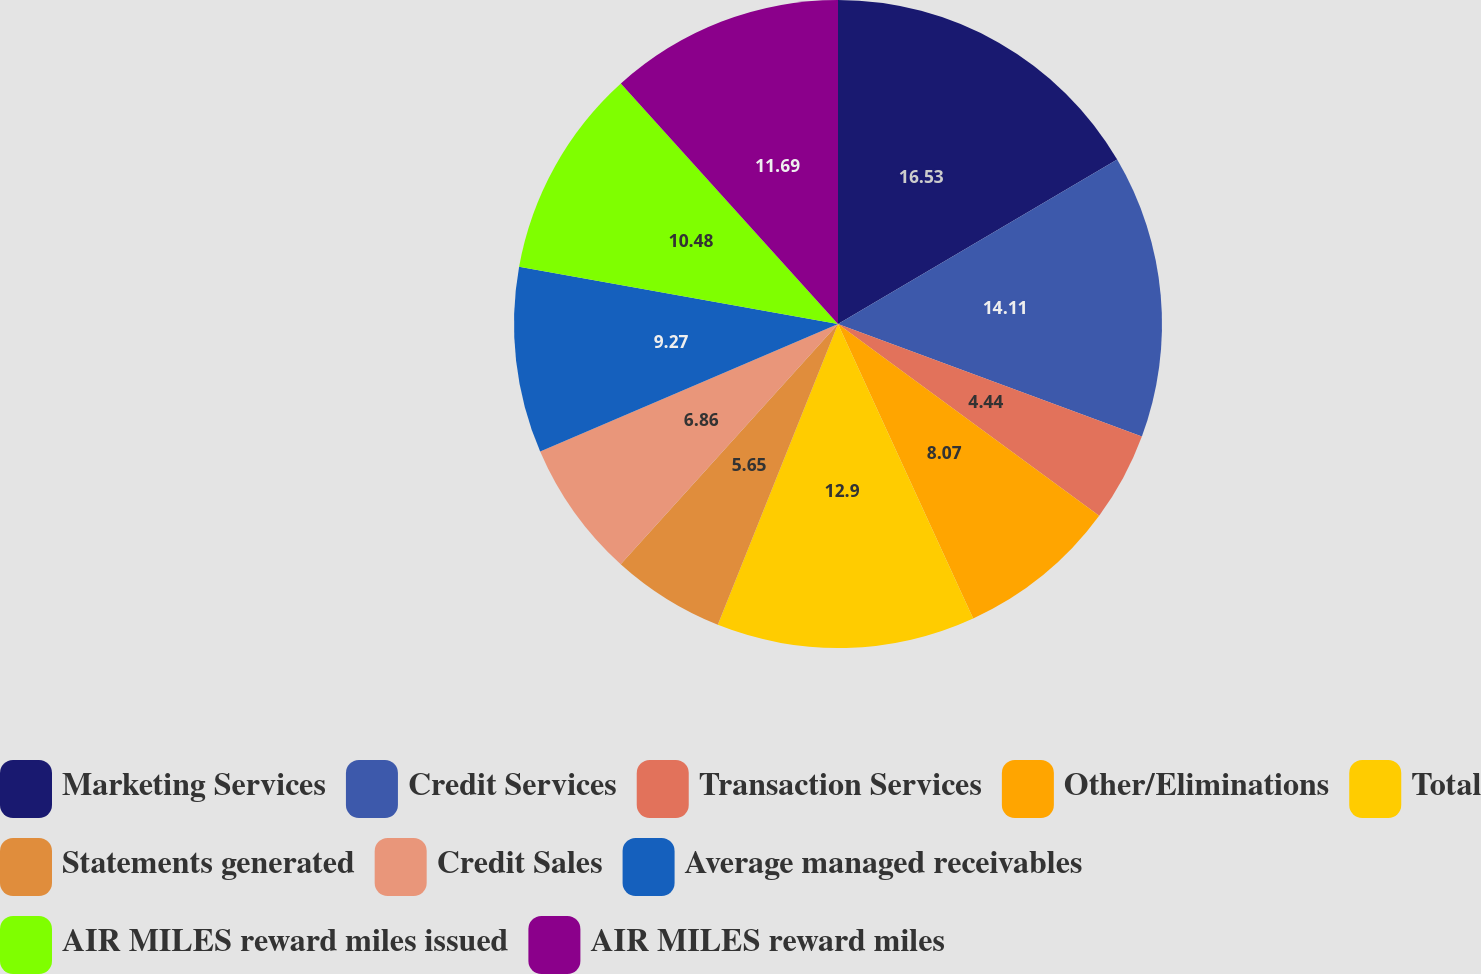Convert chart. <chart><loc_0><loc_0><loc_500><loc_500><pie_chart><fcel>Marketing Services<fcel>Credit Services<fcel>Transaction Services<fcel>Other/Eliminations<fcel>Total<fcel>Statements generated<fcel>Credit Sales<fcel>Average managed receivables<fcel>AIR MILES reward miles issued<fcel>AIR MILES reward miles<nl><fcel>16.53%<fcel>14.11%<fcel>4.44%<fcel>8.07%<fcel>12.9%<fcel>5.65%<fcel>6.86%<fcel>9.27%<fcel>10.48%<fcel>11.69%<nl></chart> 